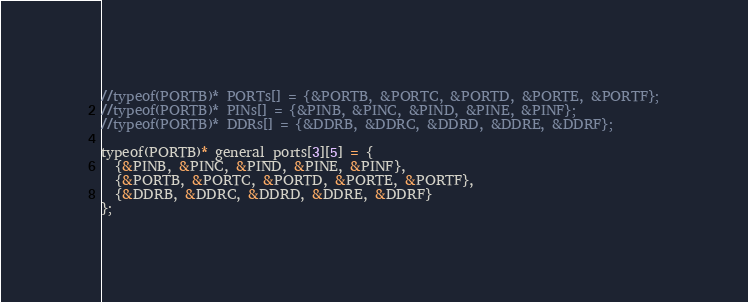<code> <loc_0><loc_0><loc_500><loc_500><_C++_>//typeof(PORTB)* PORTs[] = {&PORTB, &PORTC, &PORTD, &PORTE, &PORTF};
//typeof(PORTB)* PINs[] = {&PINB, &PINC, &PIND, &PINE, &PINF};
//typeof(PORTB)* DDRs[] = {&DDRB, &DDRC, &DDRD, &DDRE, &DDRF};

typeof(PORTB)* general_ports[3][5] = {
  {&PINB, &PINC, &PIND, &PINE, &PINF},
  {&PORTB, &PORTC, &PORTD, &PORTE, &PORTF},
  {&DDRB, &DDRC, &DDRD, &DDRE, &DDRF}
};

</code> 